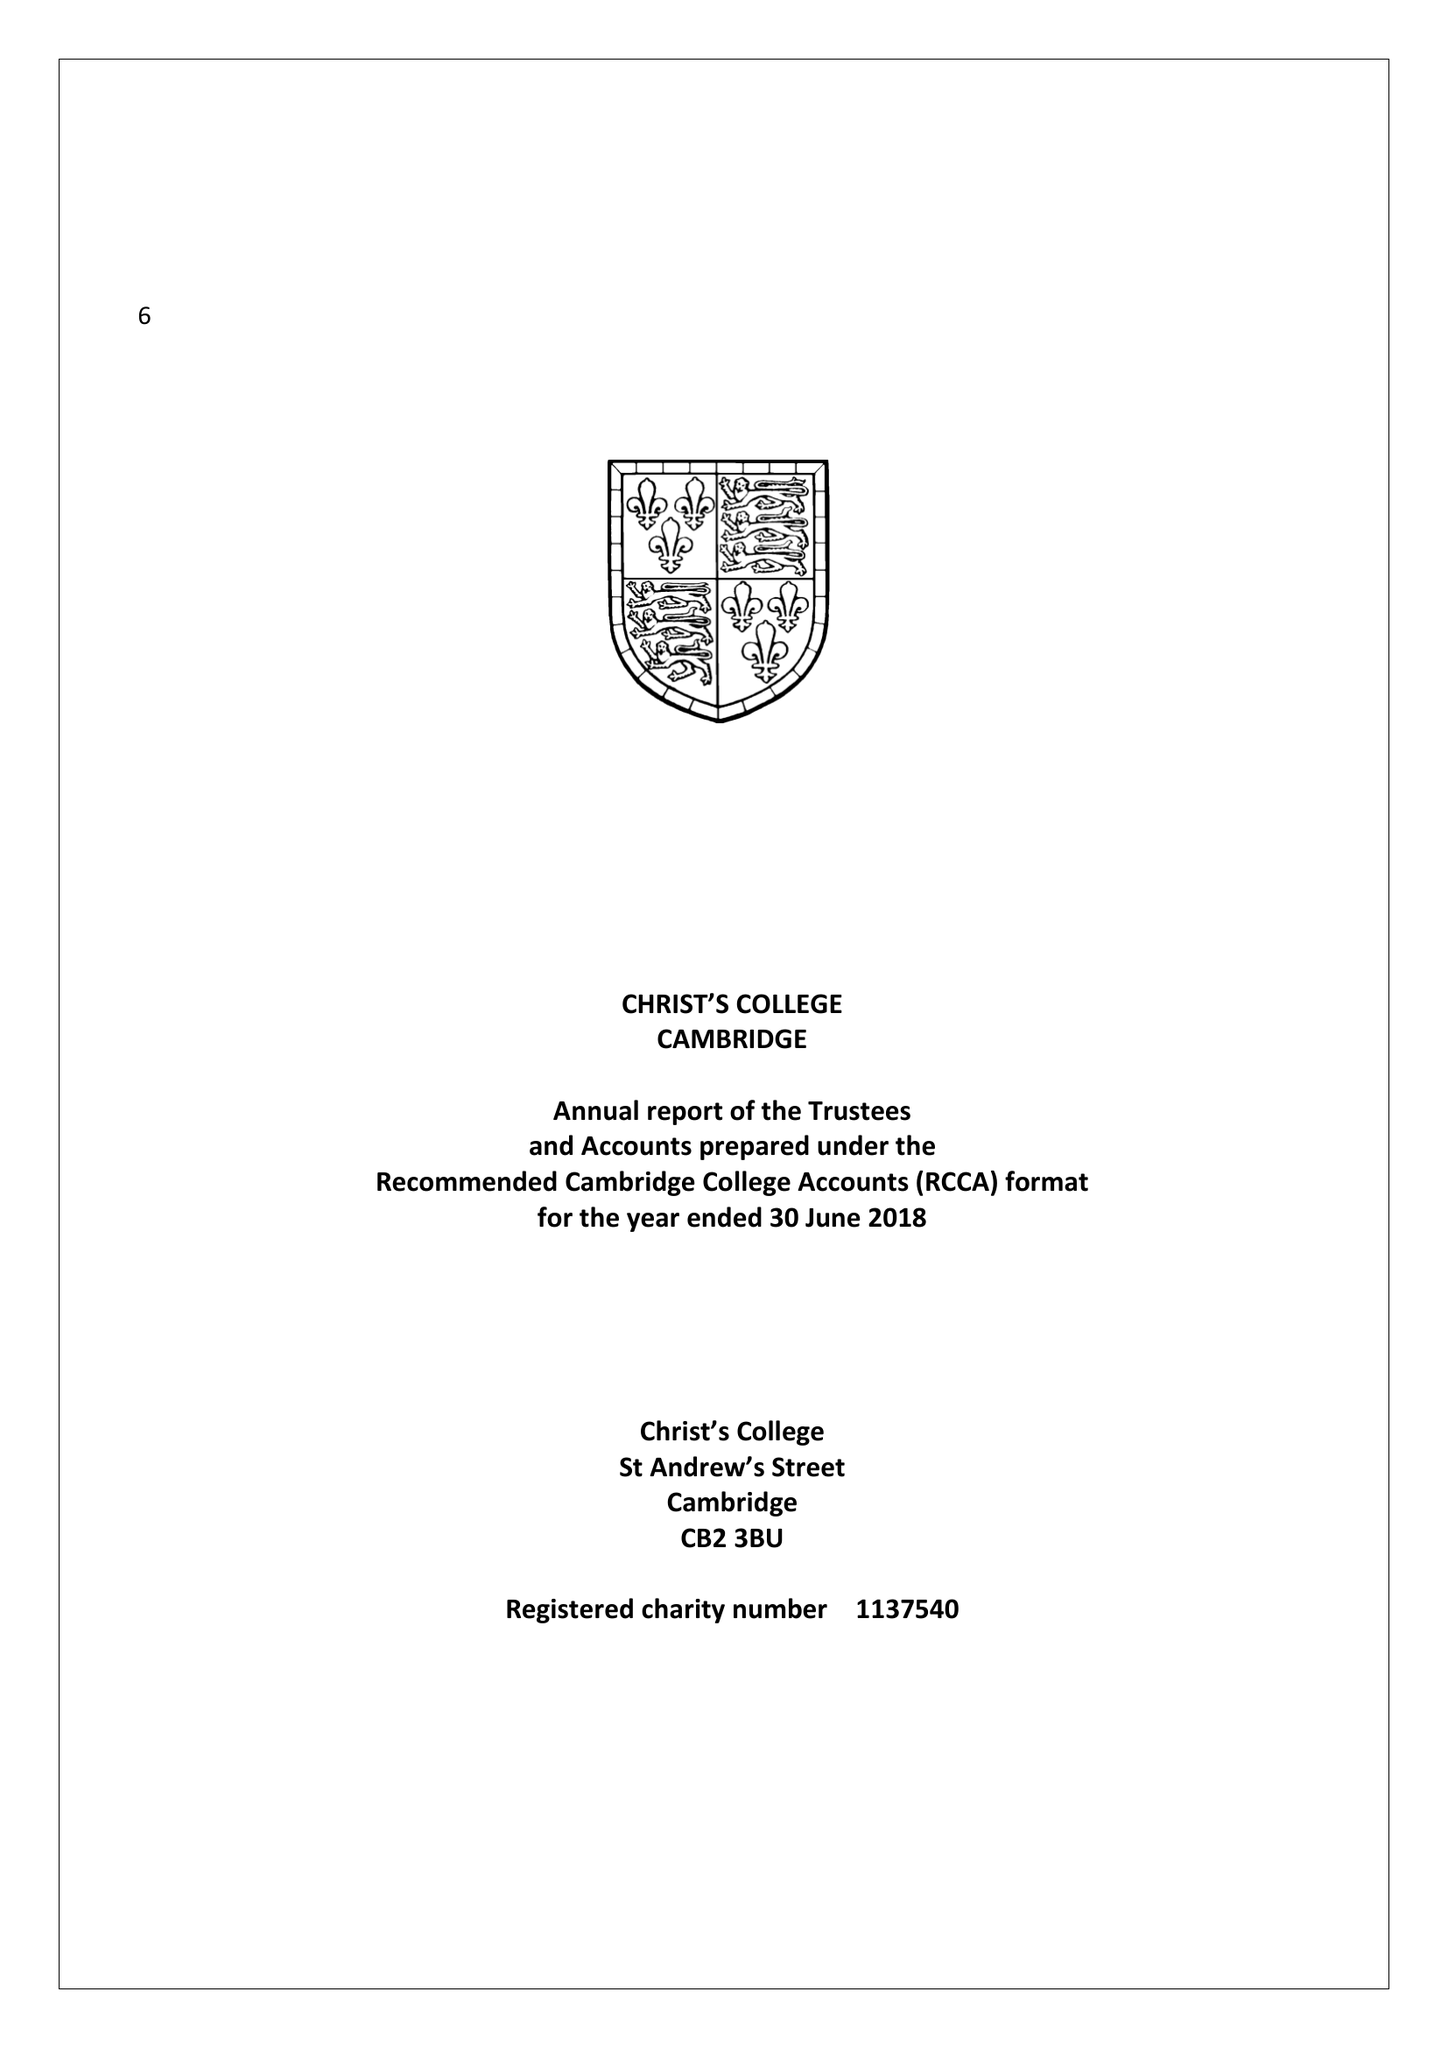What is the value for the charity_name?
Answer the question using a single word or phrase. Christ's College Cambridge In The University Of Cambridge First Founded By King Henry Vi Of England and After His Death 